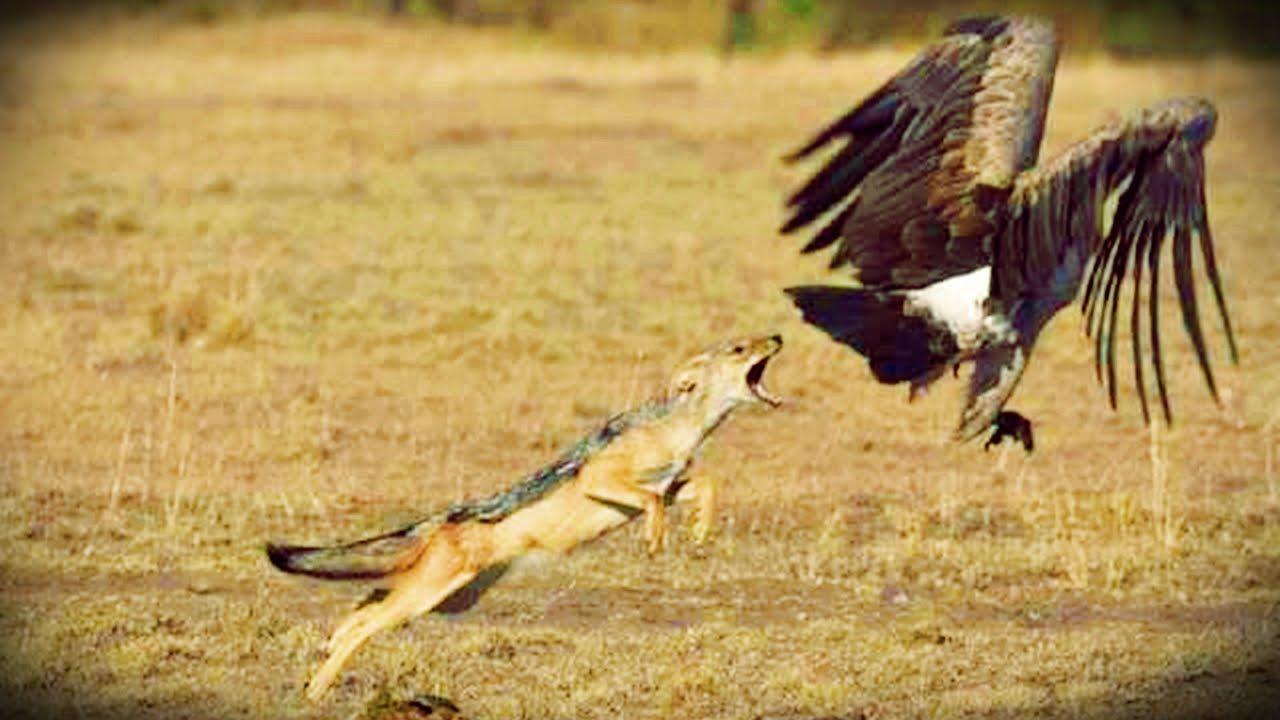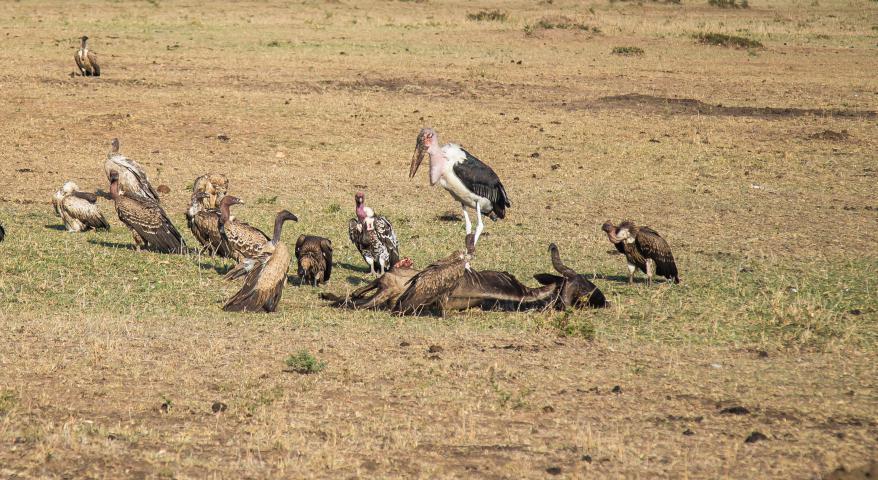The first image is the image on the left, the second image is the image on the right. Considering the images on both sides, is "None of the birds have outstretched wings in the image on the left." valid? Answer yes or no. No. 